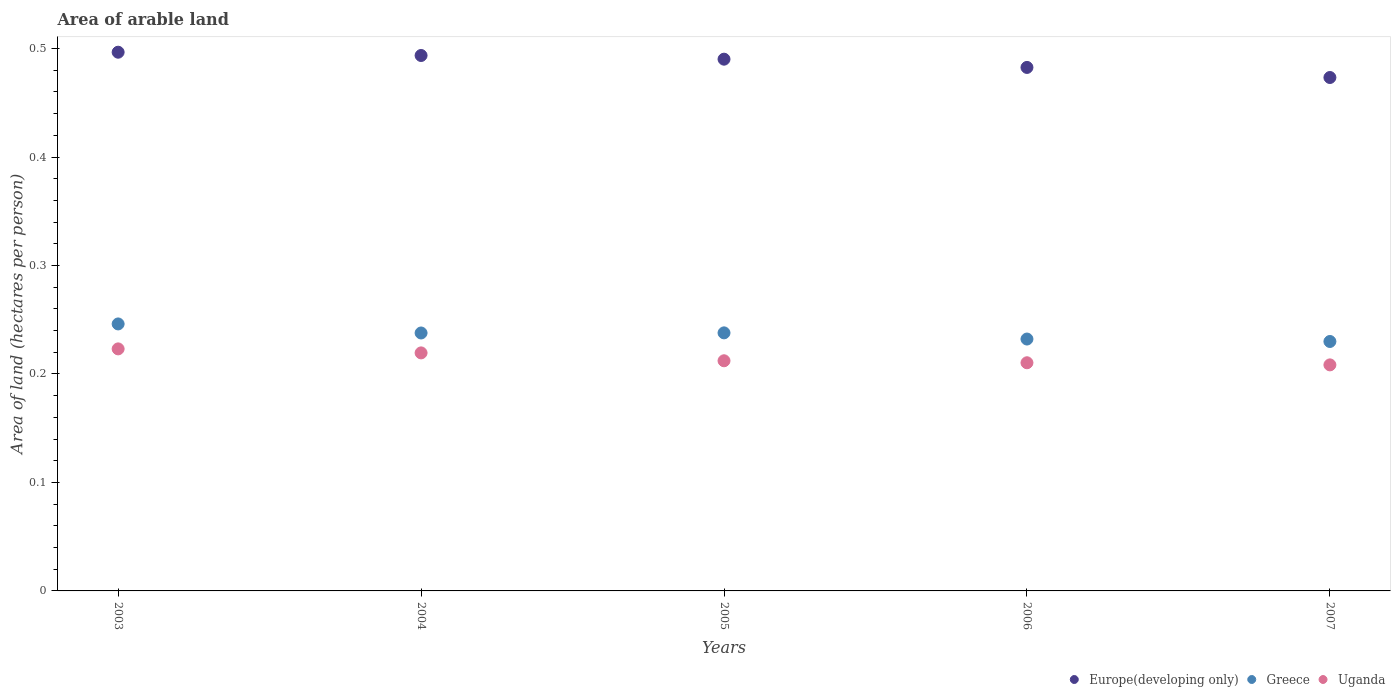What is the total arable land in Europe(developing only) in 2004?
Give a very brief answer. 0.49. Across all years, what is the maximum total arable land in Uganda?
Offer a very short reply. 0.22. Across all years, what is the minimum total arable land in Greece?
Your answer should be compact. 0.23. What is the total total arable land in Europe(developing only) in the graph?
Ensure brevity in your answer.  2.44. What is the difference between the total arable land in Greece in 2003 and that in 2006?
Your answer should be compact. 0.01. What is the difference between the total arable land in Europe(developing only) in 2004 and the total arable land in Uganda in 2007?
Your answer should be compact. 0.29. What is the average total arable land in Europe(developing only) per year?
Your answer should be compact. 0.49. In the year 2007, what is the difference between the total arable land in Uganda and total arable land in Greece?
Provide a short and direct response. -0.02. What is the ratio of the total arable land in Uganda in 2003 to that in 2006?
Provide a succinct answer. 1.06. Is the difference between the total arable land in Uganda in 2003 and 2005 greater than the difference between the total arable land in Greece in 2003 and 2005?
Make the answer very short. Yes. What is the difference between the highest and the second highest total arable land in Uganda?
Give a very brief answer. 0. What is the difference between the highest and the lowest total arable land in Greece?
Provide a short and direct response. 0.02. In how many years, is the total arable land in Uganda greater than the average total arable land in Uganda taken over all years?
Your response must be concise. 2. Is the total arable land in Europe(developing only) strictly less than the total arable land in Greece over the years?
Ensure brevity in your answer.  No. How many dotlines are there?
Your answer should be very brief. 3. How many years are there in the graph?
Your answer should be compact. 5. What is the difference between two consecutive major ticks on the Y-axis?
Provide a short and direct response. 0.1. Are the values on the major ticks of Y-axis written in scientific E-notation?
Your answer should be very brief. No. Does the graph contain any zero values?
Offer a very short reply. No. Where does the legend appear in the graph?
Give a very brief answer. Bottom right. What is the title of the graph?
Ensure brevity in your answer.  Area of arable land. Does "Dominica" appear as one of the legend labels in the graph?
Offer a very short reply. No. What is the label or title of the X-axis?
Ensure brevity in your answer.  Years. What is the label or title of the Y-axis?
Offer a very short reply. Area of land (hectares per person). What is the Area of land (hectares per person) of Europe(developing only) in 2003?
Offer a terse response. 0.5. What is the Area of land (hectares per person) in Greece in 2003?
Give a very brief answer. 0.25. What is the Area of land (hectares per person) of Uganda in 2003?
Offer a terse response. 0.22. What is the Area of land (hectares per person) in Europe(developing only) in 2004?
Offer a terse response. 0.49. What is the Area of land (hectares per person) in Greece in 2004?
Your response must be concise. 0.24. What is the Area of land (hectares per person) in Uganda in 2004?
Make the answer very short. 0.22. What is the Area of land (hectares per person) in Europe(developing only) in 2005?
Ensure brevity in your answer.  0.49. What is the Area of land (hectares per person) in Greece in 2005?
Make the answer very short. 0.24. What is the Area of land (hectares per person) of Uganda in 2005?
Make the answer very short. 0.21. What is the Area of land (hectares per person) of Europe(developing only) in 2006?
Give a very brief answer. 0.48. What is the Area of land (hectares per person) in Greece in 2006?
Provide a short and direct response. 0.23. What is the Area of land (hectares per person) in Uganda in 2006?
Offer a terse response. 0.21. What is the Area of land (hectares per person) of Europe(developing only) in 2007?
Your answer should be very brief. 0.47. What is the Area of land (hectares per person) in Greece in 2007?
Provide a short and direct response. 0.23. What is the Area of land (hectares per person) of Uganda in 2007?
Provide a short and direct response. 0.21. Across all years, what is the maximum Area of land (hectares per person) in Europe(developing only)?
Your answer should be very brief. 0.5. Across all years, what is the maximum Area of land (hectares per person) in Greece?
Your response must be concise. 0.25. Across all years, what is the maximum Area of land (hectares per person) of Uganda?
Offer a very short reply. 0.22. Across all years, what is the minimum Area of land (hectares per person) of Europe(developing only)?
Keep it short and to the point. 0.47. Across all years, what is the minimum Area of land (hectares per person) of Greece?
Keep it short and to the point. 0.23. Across all years, what is the minimum Area of land (hectares per person) in Uganda?
Ensure brevity in your answer.  0.21. What is the total Area of land (hectares per person) in Europe(developing only) in the graph?
Give a very brief answer. 2.44. What is the total Area of land (hectares per person) in Greece in the graph?
Your answer should be very brief. 1.18. What is the total Area of land (hectares per person) of Uganda in the graph?
Your answer should be very brief. 1.07. What is the difference between the Area of land (hectares per person) of Europe(developing only) in 2003 and that in 2004?
Your answer should be compact. 0. What is the difference between the Area of land (hectares per person) of Greece in 2003 and that in 2004?
Provide a succinct answer. 0.01. What is the difference between the Area of land (hectares per person) in Uganda in 2003 and that in 2004?
Your response must be concise. 0. What is the difference between the Area of land (hectares per person) of Europe(developing only) in 2003 and that in 2005?
Ensure brevity in your answer.  0.01. What is the difference between the Area of land (hectares per person) in Greece in 2003 and that in 2005?
Provide a short and direct response. 0.01. What is the difference between the Area of land (hectares per person) of Uganda in 2003 and that in 2005?
Make the answer very short. 0.01. What is the difference between the Area of land (hectares per person) in Europe(developing only) in 2003 and that in 2006?
Provide a succinct answer. 0.01. What is the difference between the Area of land (hectares per person) of Greece in 2003 and that in 2006?
Provide a succinct answer. 0.01. What is the difference between the Area of land (hectares per person) of Uganda in 2003 and that in 2006?
Provide a short and direct response. 0.01. What is the difference between the Area of land (hectares per person) in Europe(developing only) in 2003 and that in 2007?
Provide a short and direct response. 0.02. What is the difference between the Area of land (hectares per person) in Greece in 2003 and that in 2007?
Your answer should be compact. 0.02. What is the difference between the Area of land (hectares per person) in Uganda in 2003 and that in 2007?
Ensure brevity in your answer.  0.01. What is the difference between the Area of land (hectares per person) in Europe(developing only) in 2004 and that in 2005?
Your answer should be very brief. 0. What is the difference between the Area of land (hectares per person) of Greece in 2004 and that in 2005?
Provide a short and direct response. -0. What is the difference between the Area of land (hectares per person) of Uganda in 2004 and that in 2005?
Provide a short and direct response. 0.01. What is the difference between the Area of land (hectares per person) of Europe(developing only) in 2004 and that in 2006?
Offer a terse response. 0.01. What is the difference between the Area of land (hectares per person) in Greece in 2004 and that in 2006?
Ensure brevity in your answer.  0.01. What is the difference between the Area of land (hectares per person) in Uganda in 2004 and that in 2006?
Offer a terse response. 0.01. What is the difference between the Area of land (hectares per person) in Europe(developing only) in 2004 and that in 2007?
Make the answer very short. 0.02. What is the difference between the Area of land (hectares per person) of Greece in 2004 and that in 2007?
Ensure brevity in your answer.  0.01. What is the difference between the Area of land (hectares per person) of Uganda in 2004 and that in 2007?
Give a very brief answer. 0.01. What is the difference between the Area of land (hectares per person) in Europe(developing only) in 2005 and that in 2006?
Your answer should be compact. 0.01. What is the difference between the Area of land (hectares per person) in Greece in 2005 and that in 2006?
Offer a terse response. 0.01. What is the difference between the Area of land (hectares per person) in Uganda in 2005 and that in 2006?
Your answer should be compact. 0. What is the difference between the Area of land (hectares per person) in Europe(developing only) in 2005 and that in 2007?
Provide a succinct answer. 0.02. What is the difference between the Area of land (hectares per person) of Greece in 2005 and that in 2007?
Keep it short and to the point. 0.01. What is the difference between the Area of land (hectares per person) in Uganda in 2005 and that in 2007?
Offer a very short reply. 0. What is the difference between the Area of land (hectares per person) in Europe(developing only) in 2006 and that in 2007?
Ensure brevity in your answer.  0.01. What is the difference between the Area of land (hectares per person) of Greece in 2006 and that in 2007?
Make the answer very short. 0. What is the difference between the Area of land (hectares per person) of Uganda in 2006 and that in 2007?
Your response must be concise. 0. What is the difference between the Area of land (hectares per person) in Europe(developing only) in 2003 and the Area of land (hectares per person) in Greece in 2004?
Give a very brief answer. 0.26. What is the difference between the Area of land (hectares per person) in Europe(developing only) in 2003 and the Area of land (hectares per person) in Uganda in 2004?
Your answer should be very brief. 0.28. What is the difference between the Area of land (hectares per person) in Greece in 2003 and the Area of land (hectares per person) in Uganda in 2004?
Provide a short and direct response. 0.03. What is the difference between the Area of land (hectares per person) of Europe(developing only) in 2003 and the Area of land (hectares per person) of Greece in 2005?
Offer a terse response. 0.26. What is the difference between the Area of land (hectares per person) of Europe(developing only) in 2003 and the Area of land (hectares per person) of Uganda in 2005?
Offer a terse response. 0.28. What is the difference between the Area of land (hectares per person) in Greece in 2003 and the Area of land (hectares per person) in Uganda in 2005?
Keep it short and to the point. 0.03. What is the difference between the Area of land (hectares per person) of Europe(developing only) in 2003 and the Area of land (hectares per person) of Greece in 2006?
Ensure brevity in your answer.  0.26. What is the difference between the Area of land (hectares per person) of Europe(developing only) in 2003 and the Area of land (hectares per person) of Uganda in 2006?
Provide a short and direct response. 0.29. What is the difference between the Area of land (hectares per person) of Greece in 2003 and the Area of land (hectares per person) of Uganda in 2006?
Your answer should be compact. 0.04. What is the difference between the Area of land (hectares per person) of Europe(developing only) in 2003 and the Area of land (hectares per person) of Greece in 2007?
Provide a short and direct response. 0.27. What is the difference between the Area of land (hectares per person) of Europe(developing only) in 2003 and the Area of land (hectares per person) of Uganda in 2007?
Your answer should be compact. 0.29. What is the difference between the Area of land (hectares per person) of Greece in 2003 and the Area of land (hectares per person) of Uganda in 2007?
Keep it short and to the point. 0.04. What is the difference between the Area of land (hectares per person) in Europe(developing only) in 2004 and the Area of land (hectares per person) in Greece in 2005?
Ensure brevity in your answer.  0.26. What is the difference between the Area of land (hectares per person) of Europe(developing only) in 2004 and the Area of land (hectares per person) of Uganda in 2005?
Make the answer very short. 0.28. What is the difference between the Area of land (hectares per person) of Greece in 2004 and the Area of land (hectares per person) of Uganda in 2005?
Your answer should be very brief. 0.03. What is the difference between the Area of land (hectares per person) in Europe(developing only) in 2004 and the Area of land (hectares per person) in Greece in 2006?
Your answer should be compact. 0.26. What is the difference between the Area of land (hectares per person) of Europe(developing only) in 2004 and the Area of land (hectares per person) of Uganda in 2006?
Provide a succinct answer. 0.28. What is the difference between the Area of land (hectares per person) in Greece in 2004 and the Area of land (hectares per person) in Uganda in 2006?
Provide a succinct answer. 0.03. What is the difference between the Area of land (hectares per person) of Europe(developing only) in 2004 and the Area of land (hectares per person) of Greece in 2007?
Your answer should be very brief. 0.26. What is the difference between the Area of land (hectares per person) in Europe(developing only) in 2004 and the Area of land (hectares per person) in Uganda in 2007?
Provide a succinct answer. 0.29. What is the difference between the Area of land (hectares per person) of Greece in 2004 and the Area of land (hectares per person) of Uganda in 2007?
Provide a succinct answer. 0.03. What is the difference between the Area of land (hectares per person) in Europe(developing only) in 2005 and the Area of land (hectares per person) in Greece in 2006?
Your answer should be very brief. 0.26. What is the difference between the Area of land (hectares per person) in Europe(developing only) in 2005 and the Area of land (hectares per person) in Uganda in 2006?
Offer a terse response. 0.28. What is the difference between the Area of land (hectares per person) of Greece in 2005 and the Area of land (hectares per person) of Uganda in 2006?
Your answer should be compact. 0.03. What is the difference between the Area of land (hectares per person) in Europe(developing only) in 2005 and the Area of land (hectares per person) in Greece in 2007?
Make the answer very short. 0.26. What is the difference between the Area of land (hectares per person) of Europe(developing only) in 2005 and the Area of land (hectares per person) of Uganda in 2007?
Your response must be concise. 0.28. What is the difference between the Area of land (hectares per person) of Greece in 2005 and the Area of land (hectares per person) of Uganda in 2007?
Offer a terse response. 0.03. What is the difference between the Area of land (hectares per person) in Europe(developing only) in 2006 and the Area of land (hectares per person) in Greece in 2007?
Ensure brevity in your answer.  0.25. What is the difference between the Area of land (hectares per person) of Europe(developing only) in 2006 and the Area of land (hectares per person) of Uganda in 2007?
Offer a very short reply. 0.27. What is the difference between the Area of land (hectares per person) in Greece in 2006 and the Area of land (hectares per person) in Uganda in 2007?
Your response must be concise. 0.02. What is the average Area of land (hectares per person) of Europe(developing only) per year?
Your response must be concise. 0.49. What is the average Area of land (hectares per person) in Greece per year?
Your response must be concise. 0.24. What is the average Area of land (hectares per person) in Uganda per year?
Your response must be concise. 0.21. In the year 2003, what is the difference between the Area of land (hectares per person) in Europe(developing only) and Area of land (hectares per person) in Greece?
Make the answer very short. 0.25. In the year 2003, what is the difference between the Area of land (hectares per person) in Europe(developing only) and Area of land (hectares per person) in Uganda?
Your response must be concise. 0.27. In the year 2003, what is the difference between the Area of land (hectares per person) of Greece and Area of land (hectares per person) of Uganda?
Provide a succinct answer. 0.02. In the year 2004, what is the difference between the Area of land (hectares per person) in Europe(developing only) and Area of land (hectares per person) in Greece?
Make the answer very short. 0.26. In the year 2004, what is the difference between the Area of land (hectares per person) of Europe(developing only) and Area of land (hectares per person) of Uganda?
Provide a short and direct response. 0.27. In the year 2004, what is the difference between the Area of land (hectares per person) in Greece and Area of land (hectares per person) in Uganda?
Provide a succinct answer. 0.02. In the year 2005, what is the difference between the Area of land (hectares per person) of Europe(developing only) and Area of land (hectares per person) of Greece?
Keep it short and to the point. 0.25. In the year 2005, what is the difference between the Area of land (hectares per person) in Europe(developing only) and Area of land (hectares per person) in Uganda?
Offer a very short reply. 0.28. In the year 2005, what is the difference between the Area of land (hectares per person) of Greece and Area of land (hectares per person) of Uganda?
Make the answer very short. 0.03. In the year 2006, what is the difference between the Area of land (hectares per person) in Europe(developing only) and Area of land (hectares per person) in Greece?
Offer a terse response. 0.25. In the year 2006, what is the difference between the Area of land (hectares per person) in Europe(developing only) and Area of land (hectares per person) in Uganda?
Your answer should be compact. 0.27. In the year 2006, what is the difference between the Area of land (hectares per person) of Greece and Area of land (hectares per person) of Uganda?
Your answer should be compact. 0.02. In the year 2007, what is the difference between the Area of land (hectares per person) of Europe(developing only) and Area of land (hectares per person) of Greece?
Ensure brevity in your answer.  0.24. In the year 2007, what is the difference between the Area of land (hectares per person) in Europe(developing only) and Area of land (hectares per person) in Uganda?
Give a very brief answer. 0.26. In the year 2007, what is the difference between the Area of land (hectares per person) in Greece and Area of land (hectares per person) in Uganda?
Offer a very short reply. 0.02. What is the ratio of the Area of land (hectares per person) of Greece in 2003 to that in 2004?
Offer a terse response. 1.04. What is the ratio of the Area of land (hectares per person) of Uganda in 2003 to that in 2004?
Keep it short and to the point. 1.02. What is the ratio of the Area of land (hectares per person) of Europe(developing only) in 2003 to that in 2005?
Your answer should be very brief. 1.01. What is the ratio of the Area of land (hectares per person) of Greece in 2003 to that in 2005?
Your answer should be compact. 1.03. What is the ratio of the Area of land (hectares per person) of Uganda in 2003 to that in 2005?
Make the answer very short. 1.05. What is the ratio of the Area of land (hectares per person) of Europe(developing only) in 2003 to that in 2006?
Give a very brief answer. 1.03. What is the ratio of the Area of land (hectares per person) of Greece in 2003 to that in 2006?
Ensure brevity in your answer.  1.06. What is the ratio of the Area of land (hectares per person) in Uganda in 2003 to that in 2006?
Provide a succinct answer. 1.06. What is the ratio of the Area of land (hectares per person) in Europe(developing only) in 2003 to that in 2007?
Your response must be concise. 1.05. What is the ratio of the Area of land (hectares per person) of Greece in 2003 to that in 2007?
Offer a terse response. 1.07. What is the ratio of the Area of land (hectares per person) of Uganda in 2003 to that in 2007?
Your answer should be compact. 1.07. What is the ratio of the Area of land (hectares per person) of Europe(developing only) in 2004 to that in 2005?
Provide a short and direct response. 1.01. What is the ratio of the Area of land (hectares per person) in Uganda in 2004 to that in 2005?
Make the answer very short. 1.03. What is the ratio of the Area of land (hectares per person) of Europe(developing only) in 2004 to that in 2006?
Provide a short and direct response. 1.02. What is the ratio of the Area of land (hectares per person) in Greece in 2004 to that in 2006?
Provide a succinct answer. 1.02. What is the ratio of the Area of land (hectares per person) of Uganda in 2004 to that in 2006?
Ensure brevity in your answer.  1.04. What is the ratio of the Area of land (hectares per person) in Europe(developing only) in 2004 to that in 2007?
Give a very brief answer. 1.04. What is the ratio of the Area of land (hectares per person) of Greece in 2004 to that in 2007?
Offer a terse response. 1.03. What is the ratio of the Area of land (hectares per person) of Uganda in 2004 to that in 2007?
Offer a terse response. 1.05. What is the ratio of the Area of land (hectares per person) of Europe(developing only) in 2005 to that in 2006?
Provide a short and direct response. 1.02. What is the ratio of the Area of land (hectares per person) in Greece in 2005 to that in 2006?
Ensure brevity in your answer.  1.02. What is the ratio of the Area of land (hectares per person) of Uganda in 2005 to that in 2006?
Give a very brief answer. 1.01. What is the ratio of the Area of land (hectares per person) of Europe(developing only) in 2005 to that in 2007?
Your answer should be very brief. 1.04. What is the ratio of the Area of land (hectares per person) in Greece in 2005 to that in 2007?
Offer a very short reply. 1.03. What is the ratio of the Area of land (hectares per person) in Uganda in 2005 to that in 2007?
Ensure brevity in your answer.  1.02. What is the ratio of the Area of land (hectares per person) in Europe(developing only) in 2006 to that in 2007?
Provide a succinct answer. 1.02. What is the ratio of the Area of land (hectares per person) of Greece in 2006 to that in 2007?
Ensure brevity in your answer.  1.01. What is the ratio of the Area of land (hectares per person) in Uganda in 2006 to that in 2007?
Provide a succinct answer. 1.01. What is the difference between the highest and the second highest Area of land (hectares per person) in Europe(developing only)?
Your answer should be compact. 0. What is the difference between the highest and the second highest Area of land (hectares per person) of Greece?
Provide a short and direct response. 0.01. What is the difference between the highest and the second highest Area of land (hectares per person) of Uganda?
Your response must be concise. 0. What is the difference between the highest and the lowest Area of land (hectares per person) of Europe(developing only)?
Give a very brief answer. 0.02. What is the difference between the highest and the lowest Area of land (hectares per person) in Greece?
Provide a succinct answer. 0.02. What is the difference between the highest and the lowest Area of land (hectares per person) of Uganda?
Offer a very short reply. 0.01. 